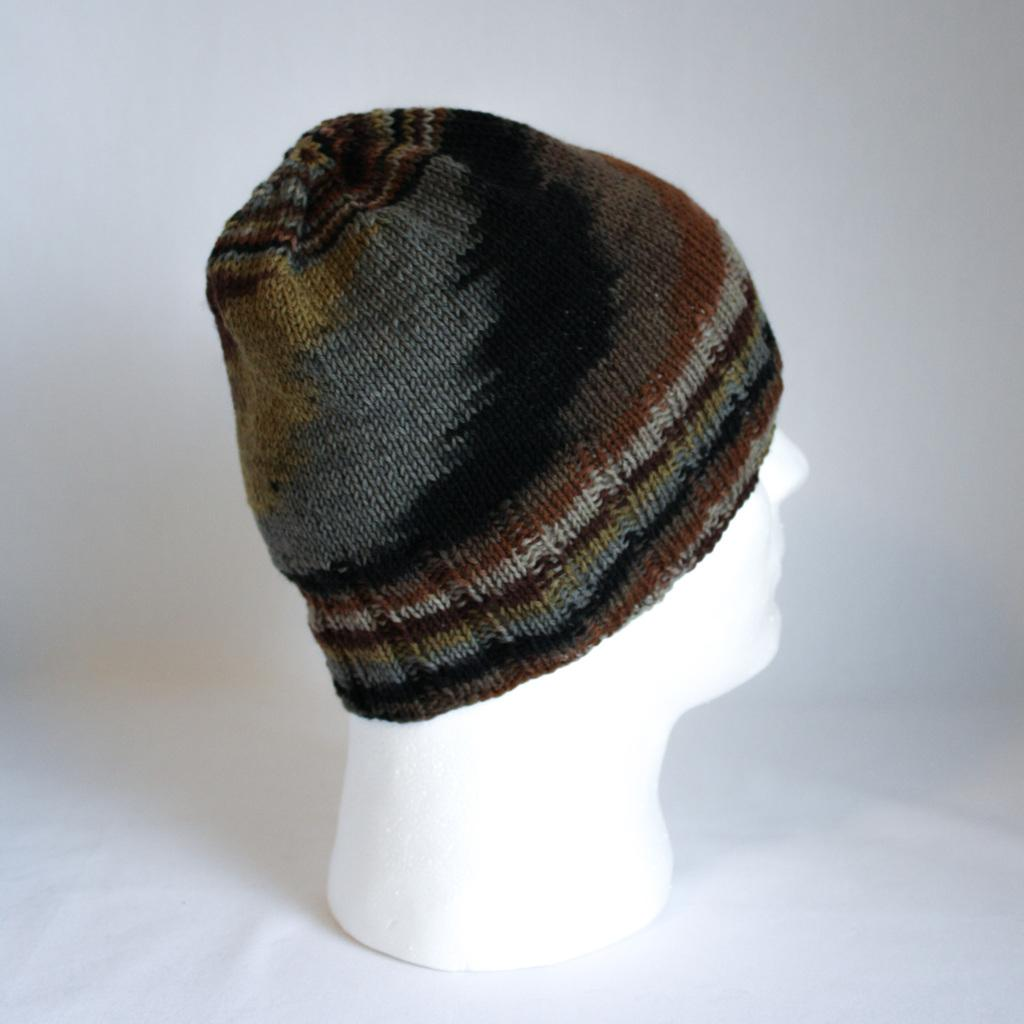What is the main subject of the image? There is a mannequin in the image. What is the mannequin wearing on its head? The mannequin is wearing a cap. What color is the background of the image? The background of the image is white. Can you see any zippers on the mannequin's clothing in the image? There are no zippers visible on the mannequin's clothing in the image. 